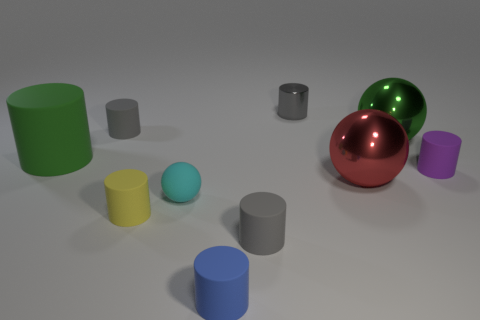Subtract all yellow balls. How many gray cylinders are left? 3 Subtract all small blue cylinders. How many cylinders are left? 6 Subtract all yellow cylinders. How many cylinders are left? 6 Subtract 4 cylinders. How many cylinders are left? 3 Subtract all blue cylinders. Subtract all cyan cubes. How many cylinders are left? 6 Subtract all cylinders. How many objects are left? 3 Subtract 0 cyan cubes. How many objects are left? 10 Subtract all purple cylinders. Subtract all tiny gray metallic objects. How many objects are left? 8 Add 6 small yellow matte things. How many small yellow matte things are left? 7 Add 8 tiny blue rubber cylinders. How many tiny blue rubber cylinders exist? 9 